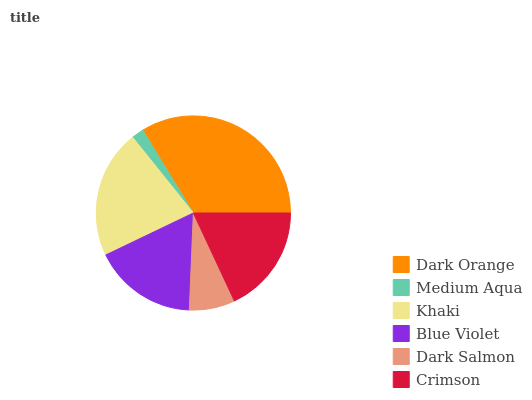Is Medium Aqua the minimum?
Answer yes or no. Yes. Is Dark Orange the maximum?
Answer yes or no. Yes. Is Khaki the minimum?
Answer yes or no. No. Is Khaki the maximum?
Answer yes or no. No. Is Khaki greater than Medium Aqua?
Answer yes or no. Yes. Is Medium Aqua less than Khaki?
Answer yes or no. Yes. Is Medium Aqua greater than Khaki?
Answer yes or no. No. Is Khaki less than Medium Aqua?
Answer yes or no. No. Is Crimson the high median?
Answer yes or no. Yes. Is Blue Violet the low median?
Answer yes or no. Yes. Is Khaki the high median?
Answer yes or no. No. Is Dark Salmon the low median?
Answer yes or no. No. 